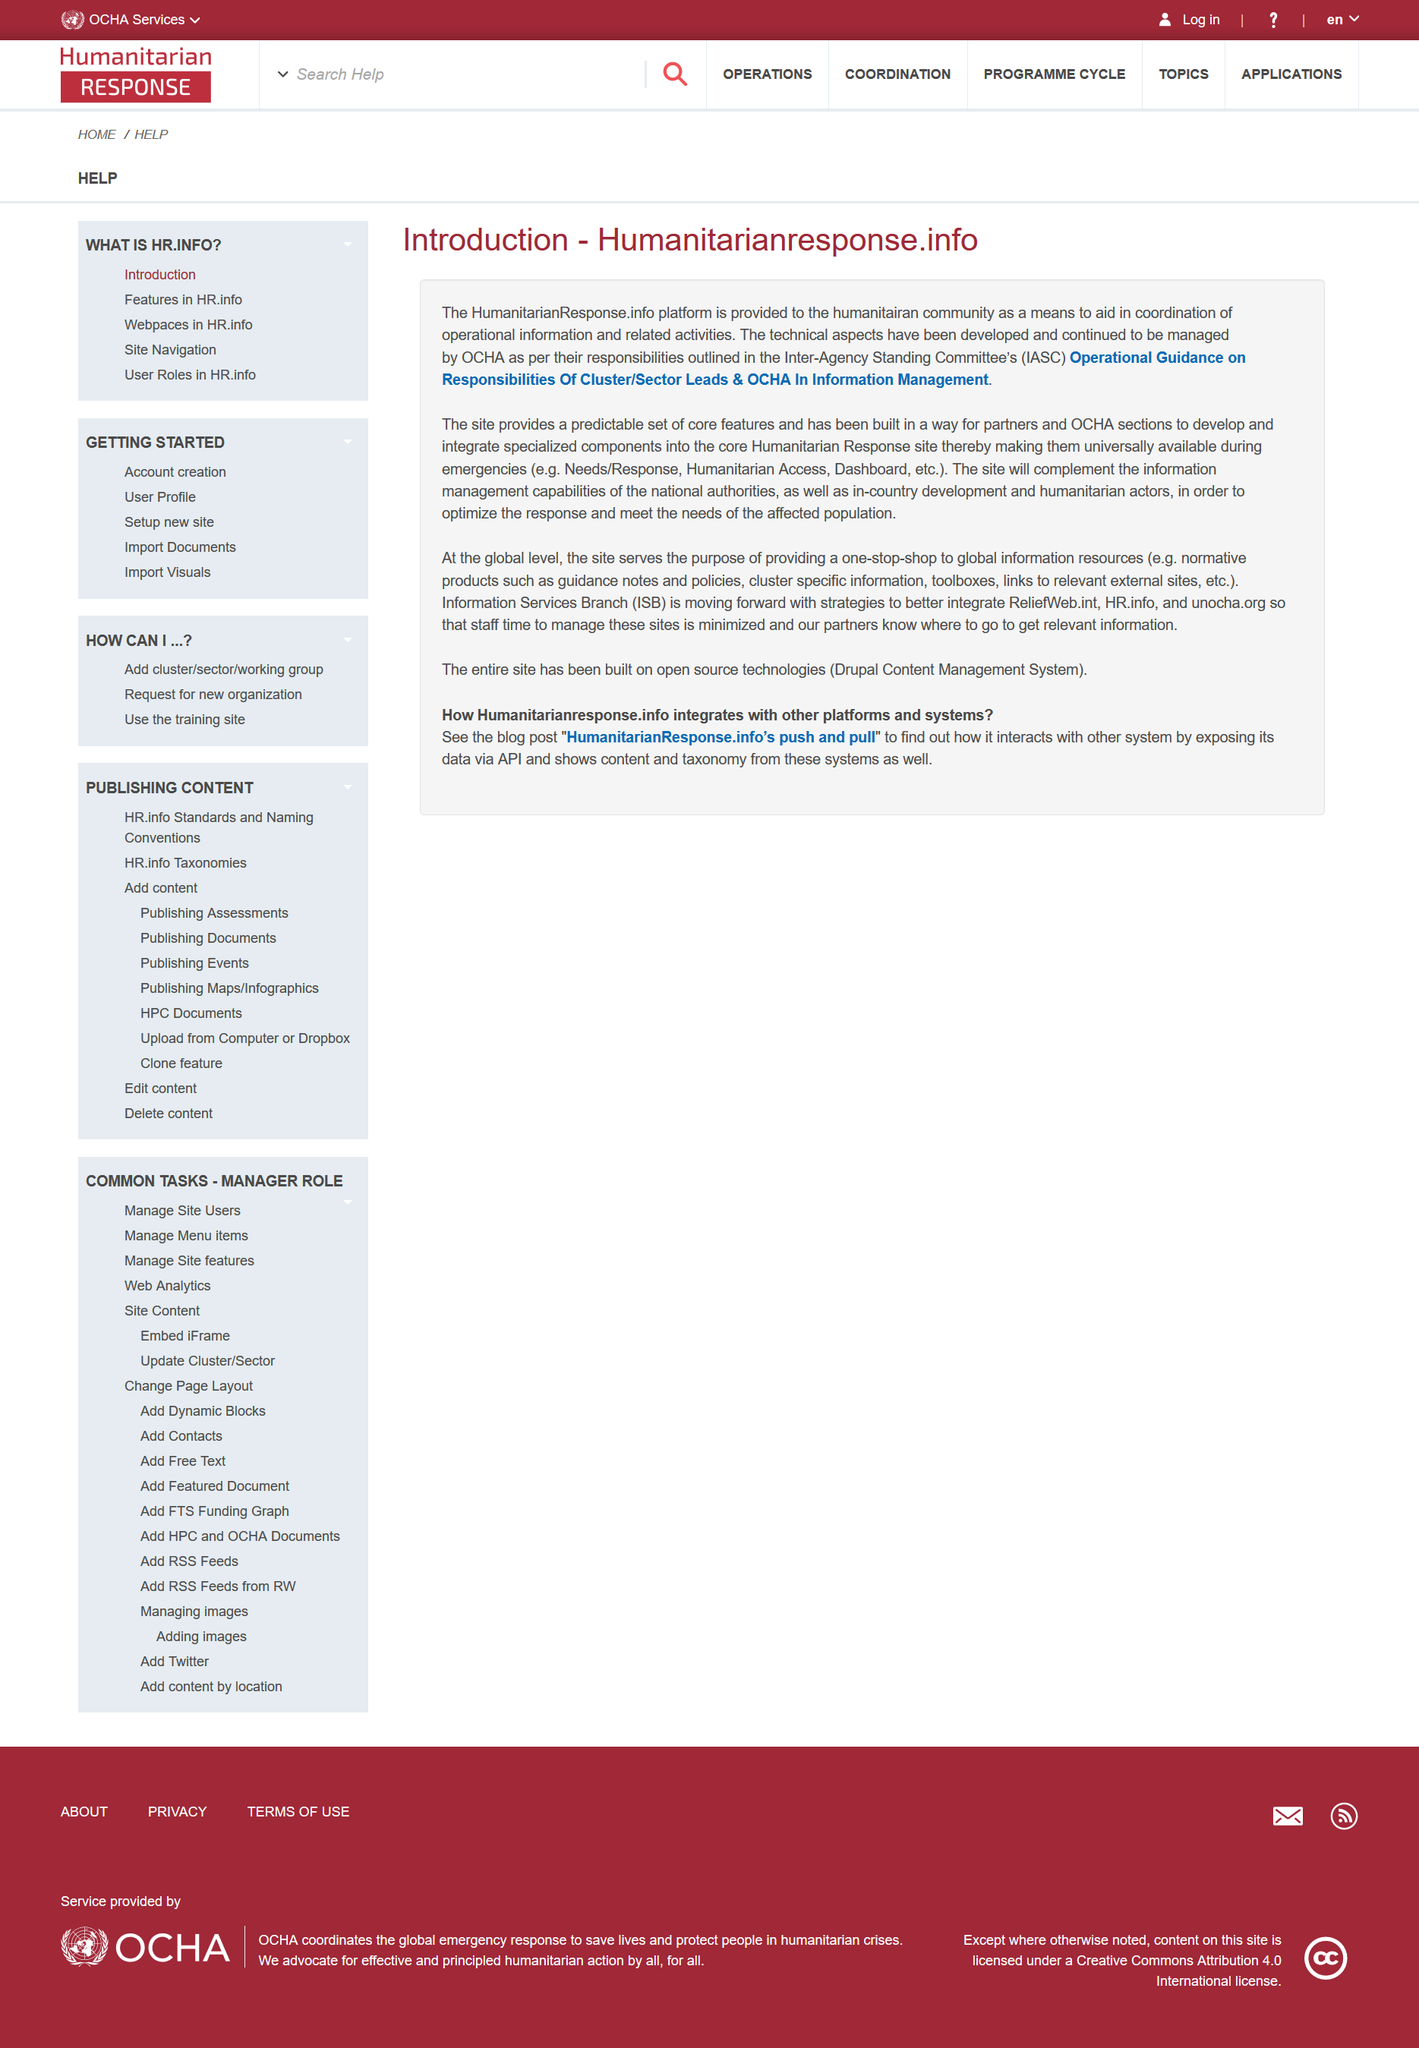Highlight a few significant elements in this photo. In addition to IASC, another acronym is referred to in the article, specifically OCHA. The HumanitarianResponse.info platform is a platform provided to the humanitarian community to aid the coordination of information and activities. The name of this platform is The Humanitarian Response Information Platform. The acronym IASC stands for Inter-Agency Standing Committee. 